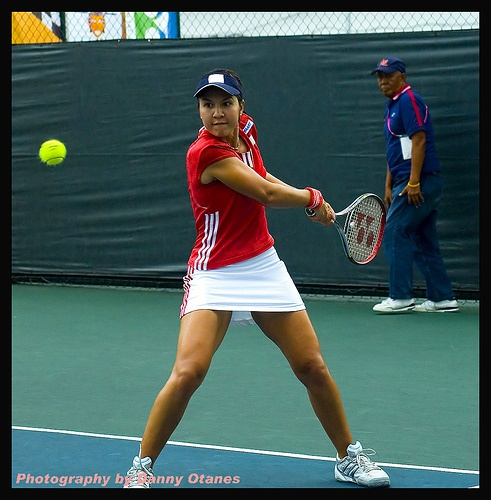Describe the objects in this image and their specific colors. I can see people in black, maroon, and white tones, people in black, navy, maroon, and teal tones, tennis racket in black, gray, darkgray, and maroon tones, and sports ball in black, yellow, olive, and darkgreen tones in this image. 